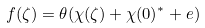<formula> <loc_0><loc_0><loc_500><loc_500>f ( \zeta ) = \theta ( \chi ( \zeta ) + \chi ( 0 ) ^ { * } + e )</formula> 